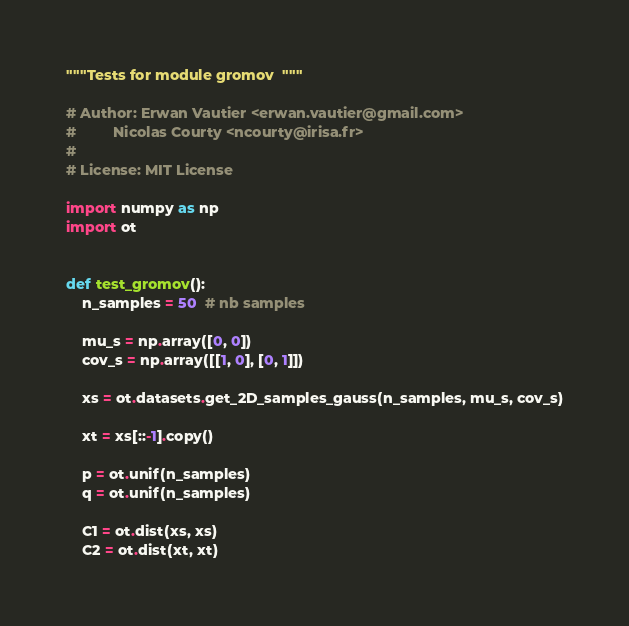<code> <loc_0><loc_0><loc_500><loc_500><_Python_>"""Tests for module gromov  """

# Author: Erwan Vautier <erwan.vautier@gmail.com>
#         Nicolas Courty <ncourty@irisa.fr>
#
# License: MIT License

import numpy as np
import ot


def test_gromov():
    n_samples = 50  # nb samples

    mu_s = np.array([0, 0])
    cov_s = np.array([[1, 0], [0, 1]])

    xs = ot.datasets.get_2D_samples_gauss(n_samples, mu_s, cov_s)

    xt = xs[::-1].copy()

    p = ot.unif(n_samples)
    q = ot.unif(n_samples)

    C1 = ot.dist(xs, xs)
    C2 = ot.dist(xt, xt)
</code> 